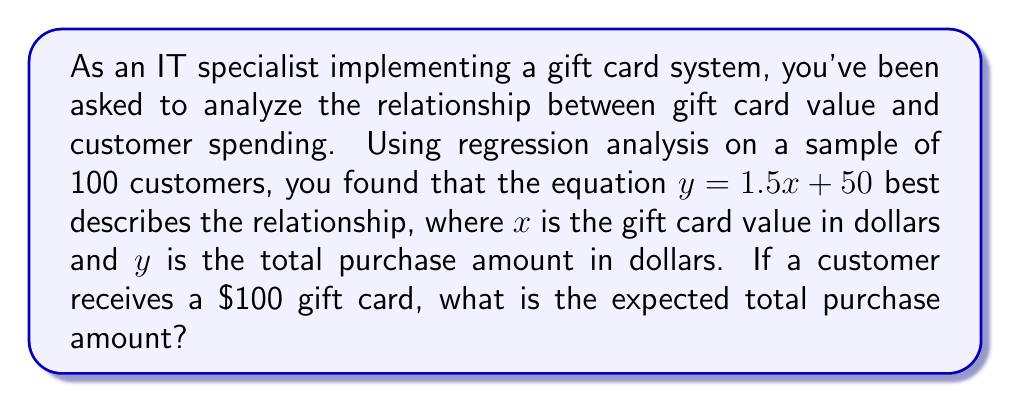Provide a solution to this math problem. To solve this problem, we'll use the linear regression equation provided:

1. The equation is in the form $y = mx + b$, where:
   $y$ = total purchase amount (dependent variable)
   $x$ = gift card value (independent variable)
   $m$ = 1.5 (slope)
   $b$ = 50 (y-intercept)

2. We're given that a customer receives a $100 gift card, so $x = 100$.

3. Substitute $x = 100$ into the equation:
   $y = 1.5x + 50$
   $y = 1.5(100) + 50$

4. Solve the equation:
   $y = 150 + 50$
   $y = 200$

Therefore, the expected total purchase amount for a customer with a $100 gift card is $200.
Answer: $200 